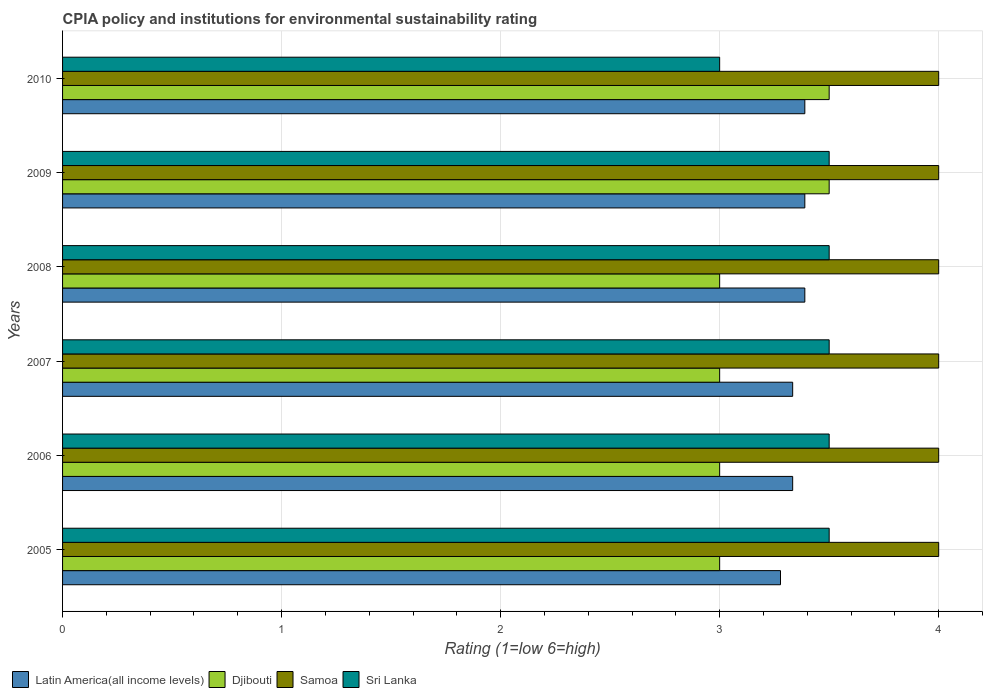How many different coloured bars are there?
Provide a short and direct response. 4. How many groups of bars are there?
Make the answer very short. 6. Are the number of bars per tick equal to the number of legend labels?
Make the answer very short. Yes. Are the number of bars on each tick of the Y-axis equal?
Give a very brief answer. Yes. How many bars are there on the 5th tick from the top?
Offer a terse response. 4. How many bars are there on the 1st tick from the bottom?
Ensure brevity in your answer.  4. What is the label of the 5th group of bars from the top?
Provide a succinct answer. 2006. What is the CPIA rating in Latin America(all income levels) in 2010?
Make the answer very short. 3.39. Across all years, what is the maximum CPIA rating in Samoa?
Keep it short and to the point. 4. Across all years, what is the minimum CPIA rating in Latin America(all income levels)?
Make the answer very short. 3.28. In which year was the CPIA rating in Djibouti minimum?
Keep it short and to the point. 2005. What is the total CPIA rating in Sri Lanka in the graph?
Offer a terse response. 20.5. What is the difference between the CPIA rating in Sri Lanka in 2005 and that in 2006?
Offer a terse response. 0. What is the difference between the CPIA rating in Latin America(all income levels) in 2009 and the CPIA rating in Sri Lanka in 2008?
Offer a very short reply. -0.11. What is the average CPIA rating in Samoa per year?
Your answer should be very brief. 4. In the year 2010, what is the difference between the CPIA rating in Latin America(all income levels) and CPIA rating in Sri Lanka?
Provide a short and direct response. 0.39. In how many years, is the CPIA rating in Samoa greater than 2.2 ?
Your response must be concise. 6. What is the ratio of the CPIA rating in Latin America(all income levels) in 2007 to that in 2010?
Provide a short and direct response. 0.98. What is the difference between the highest and the lowest CPIA rating in Latin America(all income levels)?
Your answer should be compact. 0.11. What does the 3rd bar from the top in 2005 represents?
Offer a terse response. Djibouti. What does the 1st bar from the bottom in 2006 represents?
Your answer should be very brief. Latin America(all income levels). Is it the case that in every year, the sum of the CPIA rating in Samoa and CPIA rating in Sri Lanka is greater than the CPIA rating in Latin America(all income levels)?
Provide a succinct answer. Yes. Are all the bars in the graph horizontal?
Provide a succinct answer. Yes. How many years are there in the graph?
Your response must be concise. 6. What is the difference between two consecutive major ticks on the X-axis?
Provide a short and direct response. 1. Does the graph contain grids?
Make the answer very short. Yes. How are the legend labels stacked?
Provide a succinct answer. Horizontal. What is the title of the graph?
Your answer should be compact. CPIA policy and institutions for environmental sustainability rating. Does "Sub-Saharan Africa (developing only)" appear as one of the legend labels in the graph?
Your answer should be compact. No. What is the label or title of the Y-axis?
Your response must be concise. Years. What is the Rating (1=low 6=high) in Latin America(all income levels) in 2005?
Your answer should be very brief. 3.28. What is the Rating (1=low 6=high) in Sri Lanka in 2005?
Offer a terse response. 3.5. What is the Rating (1=low 6=high) of Latin America(all income levels) in 2006?
Your answer should be compact. 3.33. What is the Rating (1=low 6=high) in Djibouti in 2006?
Provide a short and direct response. 3. What is the Rating (1=low 6=high) in Latin America(all income levels) in 2007?
Provide a short and direct response. 3.33. What is the Rating (1=low 6=high) of Djibouti in 2007?
Ensure brevity in your answer.  3. What is the Rating (1=low 6=high) in Sri Lanka in 2007?
Ensure brevity in your answer.  3.5. What is the Rating (1=low 6=high) in Latin America(all income levels) in 2008?
Ensure brevity in your answer.  3.39. What is the Rating (1=low 6=high) of Djibouti in 2008?
Keep it short and to the point. 3. What is the Rating (1=low 6=high) of Sri Lanka in 2008?
Ensure brevity in your answer.  3.5. What is the Rating (1=low 6=high) of Latin America(all income levels) in 2009?
Offer a terse response. 3.39. What is the Rating (1=low 6=high) of Djibouti in 2009?
Your answer should be compact. 3.5. What is the Rating (1=low 6=high) in Samoa in 2009?
Give a very brief answer. 4. What is the Rating (1=low 6=high) of Latin America(all income levels) in 2010?
Ensure brevity in your answer.  3.39. What is the Rating (1=low 6=high) of Djibouti in 2010?
Your answer should be very brief. 3.5. What is the Rating (1=low 6=high) in Samoa in 2010?
Your answer should be compact. 4. Across all years, what is the maximum Rating (1=low 6=high) in Latin America(all income levels)?
Offer a very short reply. 3.39. Across all years, what is the maximum Rating (1=low 6=high) in Djibouti?
Make the answer very short. 3.5. Across all years, what is the maximum Rating (1=low 6=high) of Samoa?
Ensure brevity in your answer.  4. Across all years, what is the minimum Rating (1=low 6=high) of Latin America(all income levels)?
Provide a short and direct response. 3.28. Across all years, what is the minimum Rating (1=low 6=high) in Samoa?
Give a very brief answer. 4. Across all years, what is the minimum Rating (1=low 6=high) in Sri Lanka?
Make the answer very short. 3. What is the total Rating (1=low 6=high) of Latin America(all income levels) in the graph?
Provide a short and direct response. 20.11. What is the total Rating (1=low 6=high) in Samoa in the graph?
Ensure brevity in your answer.  24. What is the total Rating (1=low 6=high) in Sri Lanka in the graph?
Give a very brief answer. 20.5. What is the difference between the Rating (1=low 6=high) in Latin America(all income levels) in 2005 and that in 2006?
Provide a succinct answer. -0.06. What is the difference between the Rating (1=low 6=high) in Djibouti in 2005 and that in 2006?
Keep it short and to the point. 0. What is the difference between the Rating (1=low 6=high) in Samoa in 2005 and that in 2006?
Provide a succinct answer. 0. What is the difference between the Rating (1=low 6=high) in Sri Lanka in 2005 and that in 2006?
Give a very brief answer. 0. What is the difference between the Rating (1=low 6=high) in Latin America(all income levels) in 2005 and that in 2007?
Make the answer very short. -0.06. What is the difference between the Rating (1=low 6=high) in Djibouti in 2005 and that in 2007?
Provide a short and direct response. 0. What is the difference between the Rating (1=low 6=high) in Sri Lanka in 2005 and that in 2007?
Your response must be concise. 0. What is the difference between the Rating (1=low 6=high) in Latin America(all income levels) in 2005 and that in 2008?
Your answer should be very brief. -0.11. What is the difference between the Rating (1=low 6=high) in Djibouti in 2005 and that in 2008?
Provide a succinct answer. 0. What is the difference between the Rating (1=low 6=high) in Samoa in 2005 and that in 2008?
Give a very brief answer. 0. What is the difference between the Rating (1=low 6=high) in Sri Lanka in 2005 and that in 2008?
Provide a succinct answer. 0. What is the difference between the Rating (1=low 6=high) of Latin America(all income levels) in 2005 and that in 2009?
Offer a terse response. -0.11. What is the difference between the Rating (1=low 6=high) of Samoa in 2005 and that in 2009?
Offer a very short reply. 0. What is the difference between the Rating (1=low 6=high) in Latin America(all income levels) in 2005 and that in 2010?
Your answer should be compact. -0.11. What is the difference between the Rating (1=low 6=high) in Samoa in 2005 and that in 2010?
Make the answer very short. 0. What is the difference between the Rating (1=low 6=high) in Sri Lanka in 2005 and that in 2010?
Keep it short and to the point. 0.5. What is the difference between the Rating (1=low 6=high) in Djibouti in 2006 and that in 2007?
Provide a short and direct response. 0. What is the difference between the Rating (1=low 6=high) of Samoa in 2006 and that in 2007?
Your answer should be compact. 0. What is the difference between the Rating (1=low 6=high) of Latin America(all income levels) in 2006 and that in 2008?
Offer a terse response. -0.06. What is the difference between the Rating (1=low 6=high) of Sri Lanka in 2006 and that in 2008?
Your answer should be very brief. 0. What is the difference between the Rating (1=low 6=high) of Latin America(all income levels) in 2006 and that in 2009?
Keep it short and to the point. -0.06. What is the difference between the Rating (1=low 6=high) of Djibouti in 2006 and that in 2009?
Make the answer very short. -0.5. What is the difference between the Rating (1=low 6=high) in Sri Lanka in 2006 and that in 2009?
Your answer should be compact. 0. What is the difference between the Rating (1=low 6=high) of Latin America(all income levels) in 2006 and that in 2010?
Provide a short and direct response. -0.06. What is the difference between the Rating (1=low 6=high) of Samoa in 2006 and that in 2010?
Give a very brief answer. 0. What is the difference between the Rating (1=low 6=high) in Sri Lanka in 2006 and that in 2010?
Ensure brevity in your answer.  0.5. What is the difference between the Rating (1=low 6=high) of Latin America(all income levels) in 2007 and that in 2008?
Your response must be concise. -0.06. What is the difference between the Rating (1=low 6=high) of Djibouti in 2007 and that in 2008?
Keep it short and to the point. 0. What is the difference between the Rating (1=low 6=high) in Samoa in 2007 and that in 2008?
Your answer should be compact. 0. What is the difference between the Rating (1=low 6=high) in Sri Lanka in 2007 and that in 2008?
Provide a succinct answer. 0. What is the difference between the Rating (1=low 6=high) in Latin America(all income levels) in 2007 and that in 2009?
Keep it short and to the point. -0.06. What is the difference between the Rating (1=low 6=high) of Djibouti in 2007 and that in 2009?
Provide a short and direct response. -0.5. What is the difference between the Rating (1=low 6=high) in Latin America(all income levels) in 2007 and that in 2010?
Your answer should be compact. -0.06. What is the difference between the Rating (1=low 6=high) in Samoa in 2007 and that in 2010?
Offer a terse response. 0. What is the difference between the Rating (1=low 6=high) in Sri Lanka in 2008 and that in 2009?
Give a very brief answer. 0. What is the difference between the Rating (1=low 6=high) in Djibouti in 2008 and that in 2010?
Keep it short and to the point. -0.5. What is the difference between the Rating (1=low 6=high) in Djibouti in 2009 and that in 2010?
Give a very brief answer. 0. What is the difference between the Rating (1=low 6=high) of Samoa in 2009 and that in 2010?
Your response must be concise. 0. What is the difference between the Rating (1=low 6=high) of Latin America(all income levels) in 2005 and the Rating (1=low 6=high) of Djibouti in 2006?
Your response must be concise. 0.28. What is the difference between the Rating (1=low 6=high) in Latin America(all income levels) in 2005 and the Rating (1=low 6=high) in Samoa in 2006?
Offer a terse response. -0.72. What is the difference between the Rating (1=low 6=high) in Latin America(all income levels) in 2005 and the Rating (1=low 6=high) in Sri Lanka in 2006?
Your answer should be very brief. -0.22. What is the difference between the Rating (1=low 6=high) in Djibouti in 2005 and the Rating (1=low 6=high) in Sri Lanka in 2006?
Give a very brief answer. -0.5. What is the difference between the Rating (1=low 6=high) of Latin America(all income levels) in 2005 and the Rating (1=low 6=high) of Djibouti in 2007?
Provide a short and direct response. 0.28. What is the difference between the Rating (1=low 6=high) of Latin America(all income levels) in 2005 and the Rating (1=low 6=high) of Samoa in 2007?
Your answer should be compact. -0.72. What is the difference between the Rating (1=low 6=high) of Latin America(all income levels) in 2005 and the Rating (1=low 6=high) of Sri Lanka in 2007?
Your answer should be compact. -0.22. What is the difference between the Rating (1=low 6=high) of Djibouti in 2005 and the Rating (1=low 6=high) of Sri Lanka in 2007?
Make the answer very short. -0.5. What is the difference between the Rating (1=low 6=high) of Samoa in 2005 and the Rating (1=low 6=high) of Sri Lanka in 2007?
Your answer should be very brief. 0.5. What is the difference between the Rating (1=low 6=high) of Latin America(all income levels) in 2005 and the Rating (1=low 6=high) of Djibouti in 2008?
Your response must be concise. 0.28. What is the difference between the Rating (1=low 6=high) in Latin America(all income levels) in 2005 and the Rating (1=low 6=high) in Samoa in 2008?
Your answer should be compact. -0.72. What is the difference between the Rating (1=low 6=high) in Latin America(all income levels) in 2005 and the Rating (1=low 6=high) in Sri Lanka in 2008?
Ensure brevity in your answer.  -0.22. What is the difference between the Rating (1=low 6=high) in Djibouti in 2005 and the Rating (1=low 6=high) in Samoa in 2008?
Your answer should be very brief. -1. What is the difference between the Rating (1=low 6=high) in Samoa in 2005 and the Rating (1=low 6=high) in Sri Lanka in 2008?
Your answer should be compact. 0.5. What is the difference between the Rating (1=low 6=high) of Latin America(all income levels) in 2005 and the Rating (1=low 6=high) of Djibouti in 2009?
Provide a short and direct response. -0.22. What is the difference between the Rating (1=low 6=high) of Latin America(all income levels) in 2005 and the Rating (1=low 6=high) of Samoa in 2009?
Offer a terse response. -0.72. What is the difference between the Rating (1=low 6=high) in Latin America(all income levels) in 2005 and the Rating (1=low 6=high) in Sri Lanka in 2009?
Provide a succinct answer. -0.22. What is the difference between the Rating (1=low 6=high) of Djibouti in 2005 and the Rating (1=low 6=high) of Samoa in 2009?
Offer a terse response. -1. What is the difference between the Rating (1=low 6=high) of Latin America(all income levels) in 2005 and the Rating (1=low 6=high) of Djibouti in 2010?
Ensure brevity in your answer.  -0.22. What is the difference between the Rating (1=low 6=high) in Latin America(all income levels) in 2005 and the Rating (1=low 6=high) in Samoa in 2010?
Provide a short and direct response. -0.72. What is the difference between the Rating (1=low 6=high) of Latin America(all income levels) in 2005 and the Rating (1=low 6=high) of Sri Lanka in 2010?
Provide a short and direct response. 0.28. What is the difference between the Rating (1=low 6=high) in Samoa in 2005 and the Rating (1=low 6=high) in Sri Lanka in 2010?
Give a very brief answer. 1. What is the difference between the Rating (1=low 6=high) of Latin America(all income levels) in 2006 and the Rating (1=low 6=high) of Djibouti in 2007?
Provide a succinct answer. 0.33. What is the difference between the Rating (1=low 6=high) in Djibouti in 2006 and the Rating (1=low 6=high) in Sri Lanka in 2007?
Your answer should be compact. -0.5. What is the difference between the Rating (1=low 6=high) of Latin America(all income levels) in 2006 and the Rating (1=low 6=high) of Djibouti in 2008?
Offer a terse response. 0.33. What is the difference between the Rating (1=low 6=high) in Latin America(all income levels) in 2006 and the Rating (1=low 6=high) in Sri Lanka in 2008?
Provide a succinct answer. -0.17. What is the difference between the Rating (1=low 6=high) of Latin America(all income levels) in 2006 and the Rating (1=low 6=high) of Sri Lanka in 2009?
Keep it short and to the point. -0.17. What is the difference between the Rating (1=low 6=high) of Djibouti in 2006 and the Rating (1=low 6=high) of Samoa in 2009?
Your response must be concise. -1. What is the difference between the Rating (1=low 6=high) in Djibouti in 2006 and the Rating (1=low 6=high) in Sri Lanka in 2009?
Offer a terse response. -0.5. What is the difference between the Rating (1=low 6=high) of Samoa in 2006 and the Rating (1=low 6=high) of Sri Lanka in 2009?
Provide a succinct answer. 0.5. What is the difference between the Rating (1=low 6=high) of Latin America(all income levels) in 2006 and the Rating (1=low 6=high) of Djibouti in 2010?
Provide a succinct answer. -0.17. What is the difference between the Rating (1=low 6=high) of Latin America(all income levels) in 2006 and the Rating (1=low 6=high) of Samoa in 2010?
Keep it short and to the point. -0.67. What is the difference between the Rating (1=low 6=high) in Djibouti in 2006 and the Rating (1=low 6=high) in Samoa in 2010?
Offer a terse response. -1. What is the difference between the Rating (1=low 6=high) in Djibouti in 2006 and the Rating (1=low 6=high) in Sri Lanka in 2010?
Your answer should be very brief. 0. What is the difference between the Rating (1=low 6=high) in Latin America(all income levels) in 2007 and the Rating (1=low 6=high) in Sri Lanka in 2008?
Your response must be concise. -0.17. What is the difference between the Rating (1=low 6=high) of Djibouti in 2007 and the Rating (1=low 6=high) of Samoa in 2008?
Ensure brevity in your answer.  -1. What is the difference between the Rating (1=low 6=high) in Djibouti in 2007 and the Rating (1=low 6=high) in Sri Lanka in 2008?
Keep it short and to the point. -0.5. What is the difference between the Rating (1=low 6=high) in Samoa in 2007 and the Rating (1=low 6=high) in Sri Lanka in 2008?
Your answer should be very brief. 0.5. What is the difference between the Rating (1=low 6=high) of Latin America(all income levels) in 2007 and the Rating (1=low 6=high) of Samoa in 2009?
Your answer should be very brief. -0.67. What is the difference between the Rating (1=low 6=high) in Latin America(all income levels) in 2007 and the Rating (1=low 6=high) in Sri Lanka in 2009?
Offer a very short reply. -0.17. What is the difference between the Rating (1=low 6=high) of Samoa in 2007 and the Rating (1=low 6=high) of Sri Lanka in 2009?
Provide a succinct answer. 0.5. What is the difference between the Rating (1=low 6=high) of Latin America(all income levels) in 2007 and the Rating (1=low 6=high) of Djibouti in 2010?
Give a very brief answer. -0.17. What is the difference between the Rating (1=low 6=high) in Latin America(all income levels) in 2007 and the Rating (1=low 6=high) in Sri Lanka in 2010?
Your answer should be very brief. 0.33. What is the difference between the Rating (1=low 6=high) of Djibouti in 2007 and the Rating (1=low 6=high) of Samoa in 2010?
Keep it short and to the point. -1. What is the difference between the Rating (1=low 6=high) of Djibouti in 2007 and the Rating (1=low 6=high) of Sri Lanka in 2010?
Ensure brevity in your answer.  0. What is the difference between the Rating (1=low 6=high) of Samoa in 2007 and the Rating (1=low 6=high) of Sri Lanka in 2010?
Keep it short and to the point. 1. What is the difference between the Rating (1=low 6=high) in Latin America(all income levels) in 2008 and the Rating (1=low 6=high) in Djibouti in 2009?
Make the answer very short. -0.11. What is the difference between the Rating (1=low 6=high) in Latin America(all income levels) in 2008 and the Rating (1=low 6=high) in Samoa in 2009?
Ensure brevity in your answer.  -0.61. What is the difference between the Rating (1=low 6=high) in Latin America(all income levels) in 2008 and the Rating (1=low 6=high) in Sri Lanka in 2009?
Offer a terse response. -0.11. What is the difference between the Rating (1=low 6=high) of Latin America(all income levels) in 2008 and the Rating (1=low 6=high) of Djibouti in 2010?
Your answer should be very brief. -0.11. What is the difference between the Rating (1=low 6=high) of Latin America(all income levels) in 2008 and the Rating (1=low 6=high) of Samoa in 2010?
Offer a terse response. -0.61. What is the difference between the Rating (1=low 6=high) of Latin America(all income levels) in 2008 and the Rating (1=low 6=high) of Sri Lanka in 2010?
Offer a terse response. 0.39. What is the difference between the Rating (1=low 6=high) of Djibouti in 2008 and the Rating (1=low 6=high) of Sri Lanka in 2010?
Offer a terse response. 0. What is the difference between the Rating (1=low 6=high) of Samoa in 2008 and the Rating (1=low 6=high) of Sri Lanka in 2010?
Your response must be concise. 1. What is the difference between the Rating (1=low 6=high) in Latin America(all income levels) in 2009 and the Rating (1=low 6=high) in Djibouti in 2010?
Your response must be concise. -0.11. What is the difference between the Rating (1=low 6=high) of Latin America(all income levels) in 2009 and the Rating (1=low 6=high) of Samoa in 2010?
Ensure brevity in your answer.  -0.61. What is the difference between the Rating (1=low 6=high) in Latin America(all income levels) in 2009 and the Rating (1=low 6=high) in Sri Lanka in 2010?
Ensure brevity in your answer.  0.39. What is the difference between the Rating (1=low 6=high) of Djibouti in 2009 and the Rating (1=low 6=high) of Samoa in 2010?
Provide a succinct answer. -0.5. What is the difference between the Rating (1=low 6=high) in Samoa in 2009 and the Rating (1=low 6=high) in Sri Lanka in 2010?
Your answer should be compact. 1. What is the average Rating (1=low 6=high) in Latin America(all income levels) per year?
Your answer should be very brief. 3.35. What is the average Rating (1=low 6=high) in Djibouti per year?
Offer a very short reply. 3.17. What is the average Rating (1=low 6=high) in Samoa per year?
Offer a very short reply. 4. What is the average Rating (1=low 6=high) in Sri Lanka per year?
Offer a terse response. 3.42. In the year 2005, what is the difference between the Rating (1=low 6=high) of Latin America(all income levels) and Rating (1=low 6=high) of Djibouti?
Offer a very short reply. 0.28. In the year 2005, what is the difference between the Rating (1=low 6=high) of Latin America(all income levels) and Rating (1=low 6=high) of Samoa?
Make the answer very short. -0.72. In the year 2005, what is the difference between the Rating (1=low 6=high) of Latin America(all income levels) and Rating (1=low 6=high) of Sri Lanka?
Offer a terse response. -0.22. In the year 2005, what is the difference between the Rating (1=low 6=high) in Djibouti and Rating (1=low 6=high) in Sri Lanka?
Provide a short and direct response. -0.5. In the year 2006, what is the difference between the Rating (1=low 6=high) in Latin America(all income levels) and Rating (1=low 6=high) in Djibouti?
Ensure brevity in your answer.  0.33. In the year 2006, what is the difference between the Rating (1=low 6=high) of Latin America(all income levels) and Rating (1=low 6=high) of Samoa?
Make the answer very short. -0.67. In the year 2006, what is the difference between the Rating (1=low 6=high) in Latin America(all income levels) and Rating (1=low 6=high) in Sri Lanka?
Keep it short and to the point. -0.17. In the year 2006, what is the difference between the Rating (1=low 6=high) of Djibouti and Rating (1=low 6=high) of Sri Lanka?
Ensure brevity in your answer.  -0.5. In the year 2006, what is the difference between the Rating (1=low 6=high) in Samoa and Rating (1=low 6=high) in Sri Lanka?
Give a very brief answer. 0.5. In the year 2007, what is the difference between the Rating (1=low 6=high) in Latin America(all income levels) and Rating (1=low 6=high) in Djibouti?
Provide a succinct answer. 0.33. In the year 2007, what is the difference between the Rating (1=low 6=high) in Latin America(all income levels) and Rating (1=low 6=high) in Samoa?
Your response must be concise. -0.67. In the year 2007, what is the difference between the Rating (1=low 6=high) of Latin America(all income levels) and Rating (1=low 6=high) of Sri Lanka?
Ensure brevity in your answer.  -0.17. In the year 2007, what is the difference between the Rating (1=low 6=high) in Djibouti and Rating (1=low 6=high) in Samoa?
Provide a short and direct response. -1. In the year 2007, what is the difference between the Rating (1=low 6=high) in Samoa and Rating (1=low 6=high) in Sri Lanka?
Provide a short and direct response. 0.5. In the year 2008, what is the difference between the Rating (1=low 6=high) of Latin America(all income levels) and Rating (1=low 6=high) of Djibouti?
Provide a short and direct response. 0.39. In the year 2008, what is the difference between the Rating (1=low 6=high) in Latin America(all income levels) and Rating (1=low 6=high) in Samoa?
Your response must be concise. -0.61. In the year 2008, what is the difference between the Rating (1=low 6=high) of Latin America(all income levels) and Rating (1=low 6=high) of Sri Lanka?
Offer a terse response. -0.11. In the year 2008, what is the difference between the Rating (1=low 6=high) of Djibouti and Rating (1=low 6=high) of Samoa?
Offer a very short reply. -1. In the year 2008, what is the difference between the Rating (1=low 6=high) in Djibouti and Rating (1=low 6=high) in Sri Lanka?
Your answer should be very brief. -0.5. In the year 2009, what is the difference between the Rating (1=low 6=high) in Latin America(all income levels) and Rating (1=low 6=high) in Djibouti?
Your answer should be compact. -0.11. In the year 2009, what is the difference between the Rating (1=low 6=high) in Latin America(all income levels) and Rating (1=low 6=high) in Samoa?
Offer a very short reply. -0.61. In the year 2009, what is the difference between the Rating (1=low 6=high) in Latin America(all income levels) and Rating (1=low 6=high) in Sri Lanka?
Provide a short and direct response. -0.11. In the year 2009, what is the difference between the Rating (1=low 6=high) in Djibouti and Rating (1=low 6=high) in Samoa?
Provide a short and direct response. -0.5. In the year 2009, what is the difference between the Rating (1=low 6=high) in Samoa and Rating (1=low 6=high) in Sri Lanka?
Ensure brevity in your answer.  0.5. In the year 2010, what is the difference between the Rating (1=low 6=high) of Latin America(all income levels) and Rating (1=low 6=high) of Djibouti?
Offer a terse response. -0.11. In the year 2010, what is the difference between the Rating (1=low 6=high) of Latin America(all income levels) and Rating (1=low 6=high) of Samoa?
Ensure brevity in your answer.  -0.61. In the year 2010, what is the difference between the Rating (1=low 6=high) in Latin America(all income levels) and Rating (1=low 6=high) in Sri Lanka?
Ensure brevity in your answer.  0.39. In the year 2010, what is the difference between the Rating (1=low 6=high) in Djibouti and Rating (1=low 6=high) in Samoa?
Offer a very short reply. -0.5. What is the ratio of the Rating (1=low 6=high) of Latin America(all income levels) in 2005 to that in 2006?
Your answer should be compact. 0.98. What is the ratio of the Rating (1=low 6=high) of Djibouti in 2005 to that in 2006?
Your answer should be very brief. 1. What is the ratio of the Rating (1=low 6=high) in Samoa in 2005 to that in 2006?
Give a very brief answer. 1. What is the ratio of the Rating (1=low 6=high) of Sri Lanka in 2005 to that in 2006?
Keep it short and to the point. 1. What is the ratio of the Rating (1=low 6=high) of Latin America(all income levels) in 2005 to that in 2007?
Your answer should be very brief. 0.98. What is the ratio of the Rating (1=low 6=high) in Djibouti in 2005 to that in 2007?
Your response must be concise. 1. What is the ratio of the Rating (1=low 6=high) of Latin America(all income levels) in 2005 to that in 2008?
Offer a very short reply. 0.97. What is the ratio of the Rating (1=low 6=high) of Samoa in 2005 to that in 2008?
Your answer should be compact. 1. What is the ratio of the Rating (1=low 6=high) of Latin America(all income levels) in 2005 to that in 2009?
Ensure brevity in your answer.  0.97. What is the ratio of the Rating (1=low 6=high) in Sri Lanka in 2005 to that in 2009?
Make the answer very short. 1. What is the ratio of the Rating (1=low 6=high) of Latin America(all income levels) in 2005 to that in 2010?
Offer a terse response. 0.97. What is the ratio of the Rating (1=low 6=high) of Sri Lanka in 2005 to that in 2010?
Provide a short and direct response. 1.17. What is the ratio of the Rating (1=low 6=high) in Latin America(all income levels) in 2006 to that in 2007?
Your answer should be very brief. 1. What is the ratio of the Rating (1=low 6=high) of Djibouti in 2006 to that in 2007?
Your response must be concise. 1. What is the ratio of the Rating (1=low 6=high) of Latin America(all income levels) in 2006 to that in 2008?
Ensure brevity in your answer.  0.98. What is the ratio of the Rating (1=low 6=high) of Sri Lanka in 2006 to that in 2008?
Give a very brief answer. 1. What is the ratio of the Rating (1=low 6=high) of Latin America(all income levels) in 2006 to that in 2009?
Provide a succinct answer. 0.98. What is the ratio of the Rating (1=low 6=high) of Samoa in 2006 to that in 2009?
Ensure brevity in your answer.  1. What is the ratio of the Rating (1=low 6=high) in Latin America(all income levels) in 2006 to that in 2010?
Make the answer very short. 0.98. What is the ratio of the Rating (1=low 6=high) in Sri Lanka in 2006 to that in 2010?
Offer a very short reply. 1.17. What is the ratio of the Rating (1=low 6=high) in Latin America(all income levels) in 2007 to that in 2008?
Your response must be concise. 0.98. What is the ratio of the Rating (1=low 6=high) in Djibouti in 2007 to that in 2008?
Offer a very short reply. 1. What is the ratio of the Rating (1=low 6=high) of Sri Lanka in 2007 to that in 2008?
Provide a short and direct response. 1. What is the ratio of the Rating (1=low 6=high) in Latin America(all income levels) in 2007 to that in 2009?
Offer a very short reply. 0.98. What is the ratio of the Rating (1=low 6=high) in Samoa in 2007 to that in 2009?
Provide a short and direct response. 1. What is the ratio of the Rating (1=low 6=high) in Sri Lanka in 2007 to that in 2009?
Give a very brief answer. 1. What is the ratio of the Rating (1=low 6=high) of Latin America(all income levels) in 2007 to that in 2010?
Your answer should be compact. 0.98. What is the ratio of the Rating (1=low 6=high) of Samoa in 2007 to that in 2010?
Keep it short and to the point. 1. What is the ratio of the Rating (1=low 6=high) in Djibouti in 2008 to that in 2009?
Give a very brief answer. 0.86. What is the ratio of the Rating (1=low 6=high) of Latin America(all income levels) in 2008 to that in 2010?
Offer a terse response. 1. What is the ratio of the Rating (1=low 6=high) of Samoa in 2008 to that in 2010?
Provide a short and direct response. 1. What is the ratio of the Rating (1=low 6=high) of Sri Lanka in 2008 to that in 2010?
Ensure brevity in your answer.  1.17. What is the ratio of the Rating (1=low 6=high) in Sri Lanka in 2009 to that in 2010?
Provide a short and direct response. 1.17. What is the difference between the highest and the second highest Rating (1=low 6=high) in Latin America(all income levels)?
Keep it short and to the point. 0. What is the difference between the highest and the second highest Rating (1=low 6=high) in Djibouti?
Give a very brief answer. 0. What is the difference between the highest and the lowest Rating (1=low 6=high) of Latin America(all income levels)?
Your answer should be very brief. 0.11. What is the difference between the highest and the lowest Rating (1=low 6=high) in Djibouti?
Offer a very short reply. 0.5. What is the difference between the highest and the lowest Rating (1=low 6=high) of Sri Lanka?
Offer a terse response. 0.5. 